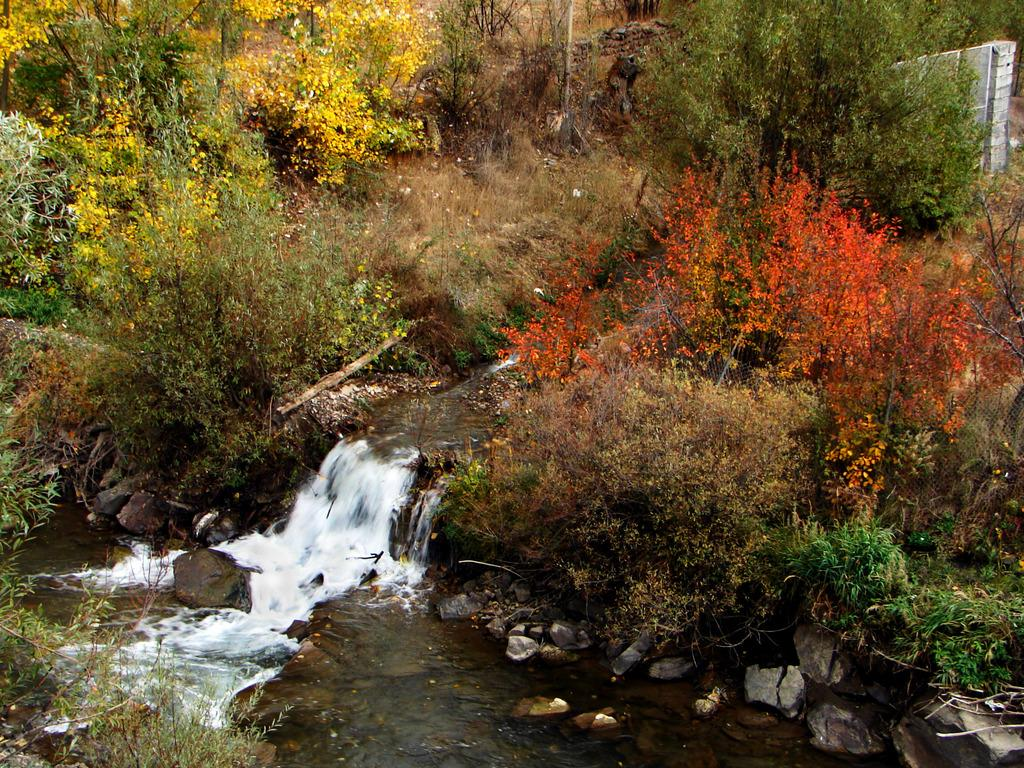What is the primary element visible in the image? There is water in the image. What other objects can be seen in the image? There are stones in the image. What types of vegetation are present in the background of the image? There are flowers with orange and yellow colors, as well as plants with green colors in the background of the image. Where is the shop located in the image? There is no shop present in the image. Can you describe the kitty playing with the stones in the image? There is no kitty present in the image; it only features water, stones, and vegetation. 